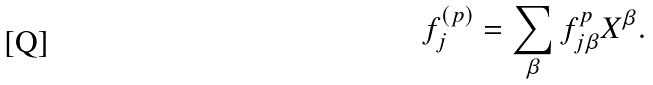Convert formula to latex. <formula><loc_0><loc_0><loc_500><loc_500>f _ { j } ^ { ( p ) } = \sum _ { \beta } f _ { j \beta } ^ { p } X ^ { \beta } .</formula> 